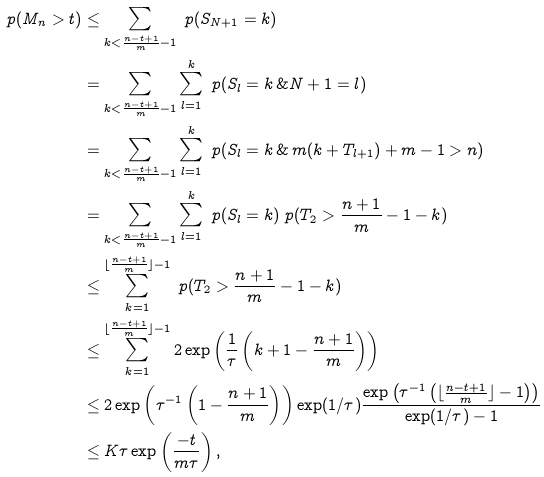<formula> <loc_0><loc_0><loc_500><loc_500>\ p ( M _ { n } > t ) & \leq \sum _ { k < \frac { n - t + 1 } { m } - 1 } \ p ( S _ { N + 1 } = k ) \\ & = \sum _ { k < \frac { n - t + 1 } { m } - 1 } \sum _ { l = 1 } ^ { k } \ p ( S _ { l } = k \, \& { N + 1 } = l ) \\ & = \sum _ { k < \frac { n - t + 1 } { m } - 1 } \sum _ { l = 1 } ^ { k } \ p ( S _ { l } = k \, \& \, m ( k + T _ { l + 1 } ) + m - 1 > n ) \\ & = \sum _ { k < \frac { n - t + 1 } { m } - 1 } \sum _ { l = 1 } ^ { k } \ p ( S _ { l } = k ) \ p ( T _ { 2 } > \frac { n + 1 } { m } - 1 - k ) \\ & \leq \sum _ { k = 1 } ^ { \lfloor \frac { n - t + 1 } { m } \rfloor - 1 } \ p ( T _ { 2 } > \frac { n + 1 } { m } - 1 - k ) \\ & \leq \sum _ { k = 1 } ^ { \lfloor \frac { n - t + 1 } { m } \rfloor - 1 } 2 \exp \left ( \frac { 1 } { \tau } \left ( k + 1 - \frac { n + 1 } { m } \right ) \right ) \\ & \leq 2 \exp \left ( \tau ^ { - 1 } \left ( 1 - \frac { n + 1 } { m } \right ) \right ) \exp ( 1 / \tau ) \frac { \exp \left ( \tau ^ { - 1 } \left ( \lfloor \frac { n - t + 1 } { m } \rfloor - 1 \right ) \right ) } { \exp ( 1 / \tau ) - 1 } \\ & \leq K \tau \exp \left ( \frac { - t } { m \tau } \right ) ,</formula> 